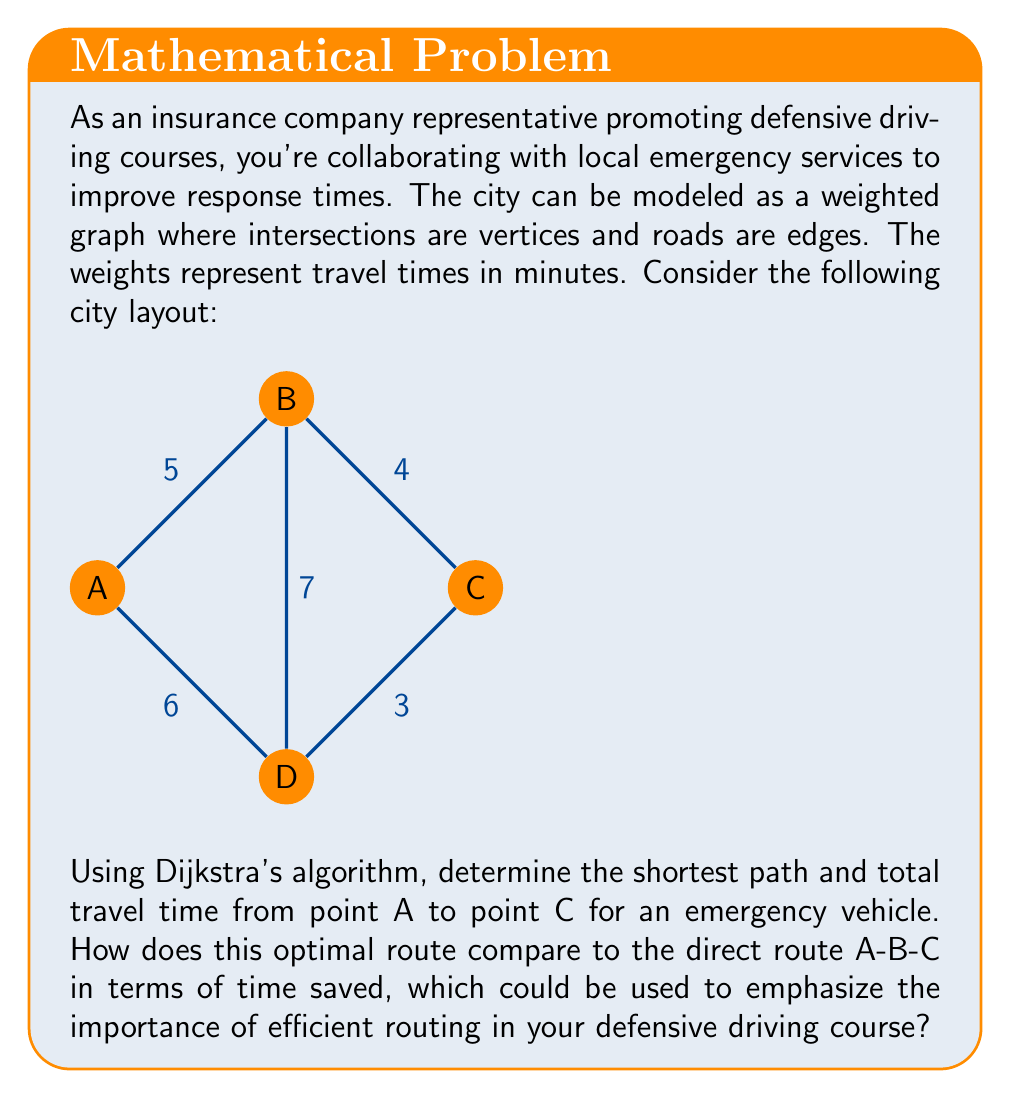Could you help me with this problem? Let's solve this step-by-step using Dijkstra's algorithm:

1) Initialize:
   - Set distance to A as 0, all others as infinity.
   - Set all nodes as unvisited.
   - Set A as the current node.

2) For the current node, consider all unvisited neighbors and calculate their tentative distances:
   - A to B: 5 minutes
   - A to D: 6 minutes

3) Mark A as visited. B has the smallest tentative distance, so make B the current node.

4) From B:
   - B to C: 5 + 4 = 9 minutes
   - B to D: 5 + 7 = 12 minutes (longer than direct A to D)

5) Mark B as visited. D has the smallest tentative distance among unvisited nodes, so make D the current node.

6) From D:
   - D to C: 6 + 3 = 9 minutes

7) Mark D as visited. C is the only unvisited node left, so it becomes the current node.

8) The algorithm is complete. The shortest path from A to C is A-D-C with a total time of 9 minutes.

Comparing to the direct route A-B-C:
- A-B-C route time: 5 + 4 = 9 minutes
- Optimal A-D-C route time: 9 minutes

In this case, the optimal route doesn't save time compared to the direct route. However, this demonstrates the importance of considering all possible routes, as in many real-world scenarios, the direct route isn't always the fastest. This concept can be emphasized in defensive driving courses to highlight the importance of route knowledge and adaptability in emergency situations.

The time saved is:
$$\text{Time saved} = \text{Direct route time} - \text{Optimal route time} = 9 - 9 = 0 \text{ minutes}$$
Answer: Optimal path: A-D-C, Total time: 9 minutes, Time saved: 0 minutes 